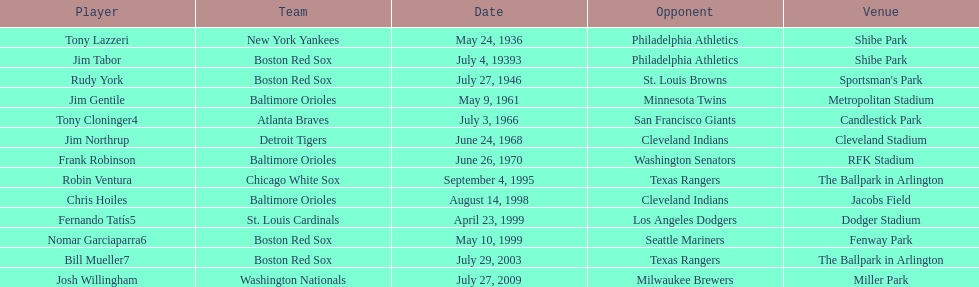What is the name of the player for the new york yankees in 1936? Tony Lazzeri. 